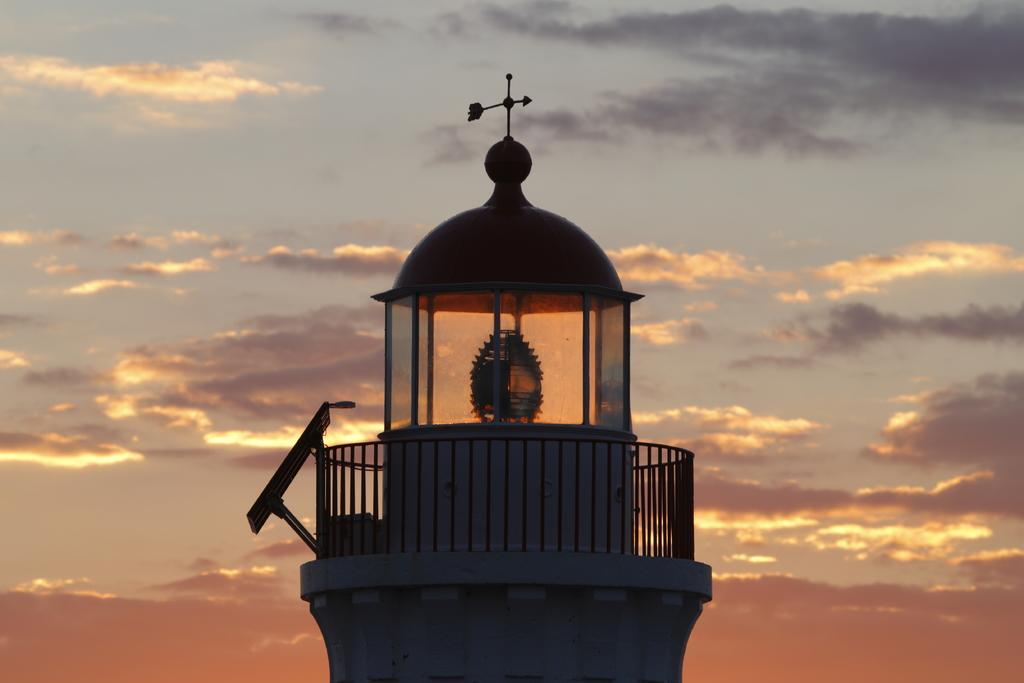Could you give a brief overview of what you see in this image? In this picture we can see a lighthouse and the cloudy sky in the background. 